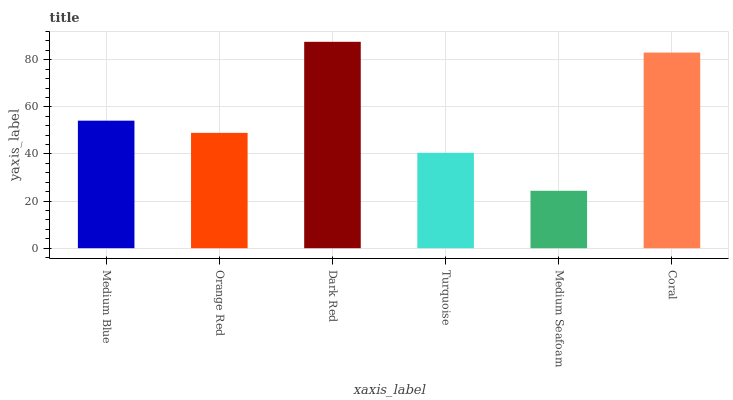Is Orange Red the minimum?
Answer yes or no. No. Is Orange Red the maximum?
Answer yes or no. No. Is Medium Blue greater than Orange Red?
Answer yes or no. Yes. Is Orange Red less than Medium Blue?
Answer yes or no. Yes. Is Orange Red greater than Medium Blue?
Answer yes or no. No. Is Medium Blue less than Orange Red?
Answer yes or no. No. Is Medium Blue the high median?
Answer yes or no. Yes. Is Orange Red the low median?
Answer yes or no. Yes. Is Dark Red the high median?
Answer yes or no. No. Is Coral the low median?
Answer yes or no. No. 